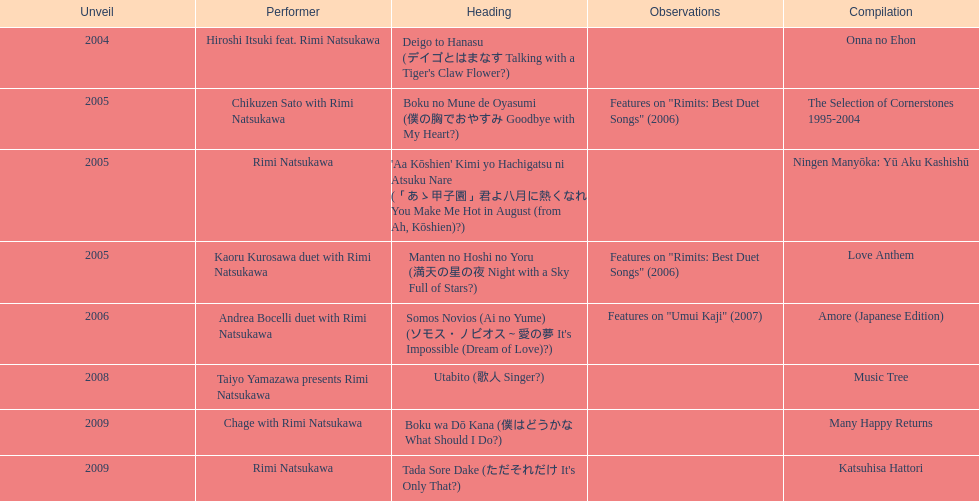Which was not released in 2004, onna no ehon or music tree? Music Tree. 